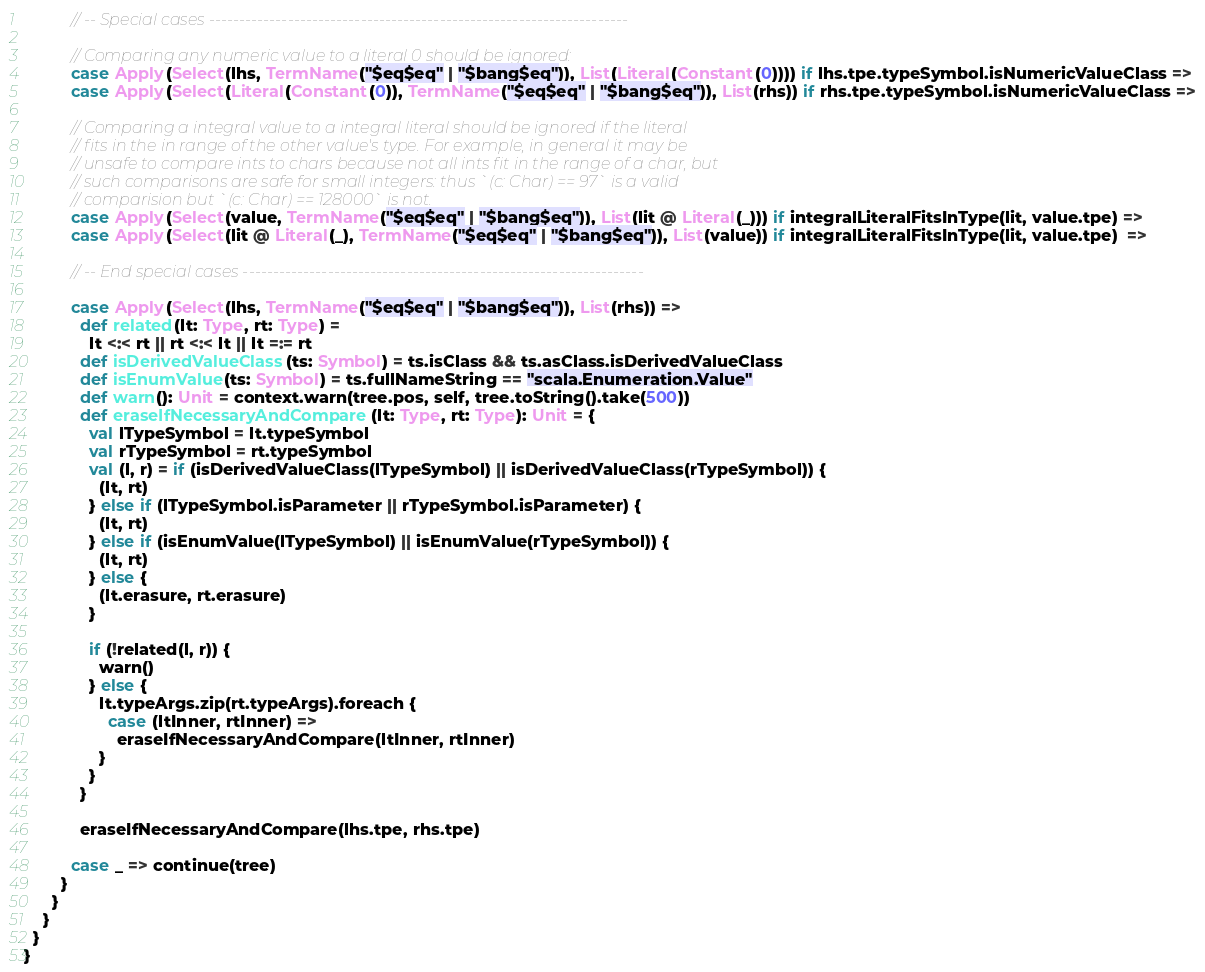Convert code to text. <code><loc_0><loc_0><loc_500><loc_500><_Scala_>          // -- Special cases ---------------------------------------------------------------------

          // Comparing any numeric value to a literal 0 should be ignored:
          case Apply(Select(lhs, TermName("$eq$eq" | "$bang$eq")), List(Literal(Constant(0)))) if lhs.tpe.typeSymbol.isNumericValueClass =>
          case Apply(Select(Literal(Constant(0)), TermName("$eq$eq" | "$bang$eq")), List(rhs)) if rhs.tpe.typeSymbol.isNumericValueClass =>

          // Comparing a integral value to a integral literal should be ignored if the literal
          // fits in the in range of the other value's type. For example, in general it may be
          // unsafe to compare ints to chars because not all ints fit in the range of a char, but
          // such comparisons are safe for small integers: thus `(c: Char) == 97` is a valid
          // comparision but `(c: Char) == 128000` is not.
          case Apply(Select(value, TermName("$eq$eq" | "$bang$eq")), List(lit @ Literal(_))) if integralLiteralFitsInType(lit, value.tpe) =>
          case Apply(Select(lit @ Literal(_), TermName("$eq$eq" | "$bang$eq")), List(value)) if integralLiteralFitsInType(lit, value.tpe)  =>

          // -- End special cases ------------------------------------------------------------------

          case Apply(Select(lhs, TermName("$eq$eq" | "$bang$eq")), List(rhs)) =>
            def related(lt: Type, rt: Type) =
              lt <:< rt || rt <:< lt || lt =:= rt
            def isDerivedValueClass(ts: Symbol) = ts.isClass && ts.asClass.isDerivedValueClass
            def isEnumValue(ts: Symbol) = ts.fullNameString == "scala.Enumeration.Value"
            def warn(): Unit = context.warn(tree.pos, self, tree.toString().take(500))
            def eraseIfNecessaryAndCompare(lt: Type, rt: Type): Unit = {
              val lTypeSymbol = lt.typeSymbol
              val rTypeSymbol = rt.typeSymbol
              val (l, r) = if (isDerivedValueClass(lTypeSymbol) || isDerivedValueClass(rTypeSymbol)) {
                (lt, rt)
              } else if (lTypeSymbol.isParameter || rTypeSymbol.isParameter) {
                (lt, rt)
              } else if (isEnumValue(lTypeSymbol) || isEnumValue(rTypeSymbol)) {
                (lt, rt)
              } else {
                (lt.erasure, rt.erasure)
              }

              if (!related(l, r)) {
                warn()
              } else {
                lt.typeArgs.zip(rt.typeArgs).foreach {
                  case (ltInner, rtInner) =>
                    eraseIfNecessaryAndCompare(ltInner, rtInner)
                }
              }
            }

            eraseIfNecessaryAndCompare(lhs.tpe, rhs.tpe)

          case _ => continue(tree)
        }
      }
    }
  }
}
</code> 